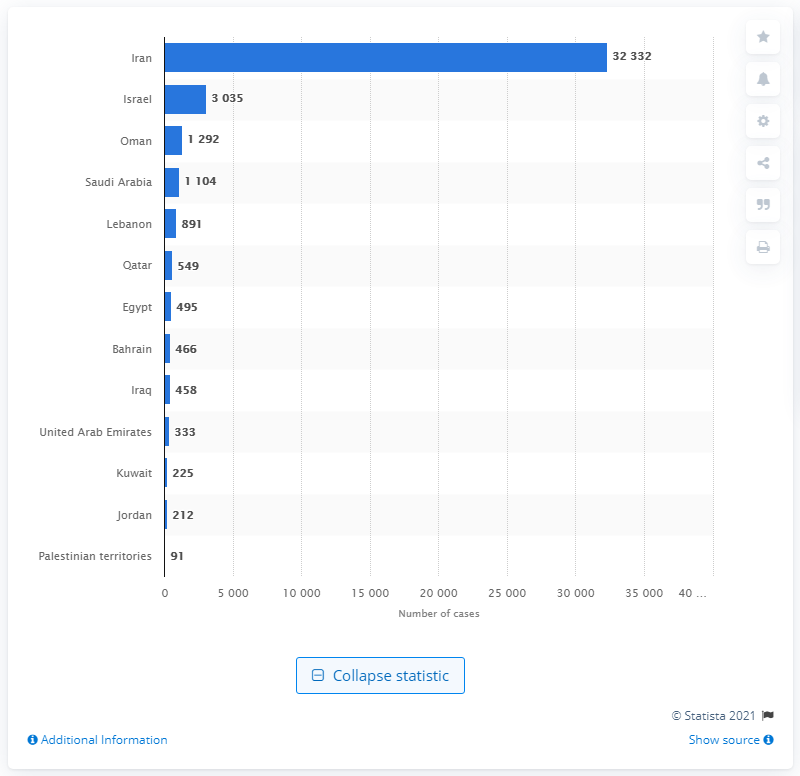Draw attention to some important aspects in this diagram. The United Arab Emirates was the first country in the region to report a case of the coronavirus. Iran had the largest number of coronavirus cases in the Middle East and North Africa as of March 2020, according to data available. 